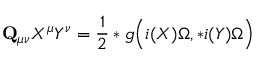<formula> <loc_0><loc_0><loc_500><loc_500>{ Q } _ { \mu \nu } X ^ { \mu } Y ^ { \nu } = \frac { 1 } { 2 } * g \left ( i ( X ) \Omega , * i ( Y ) \Omega \right )</formula> 